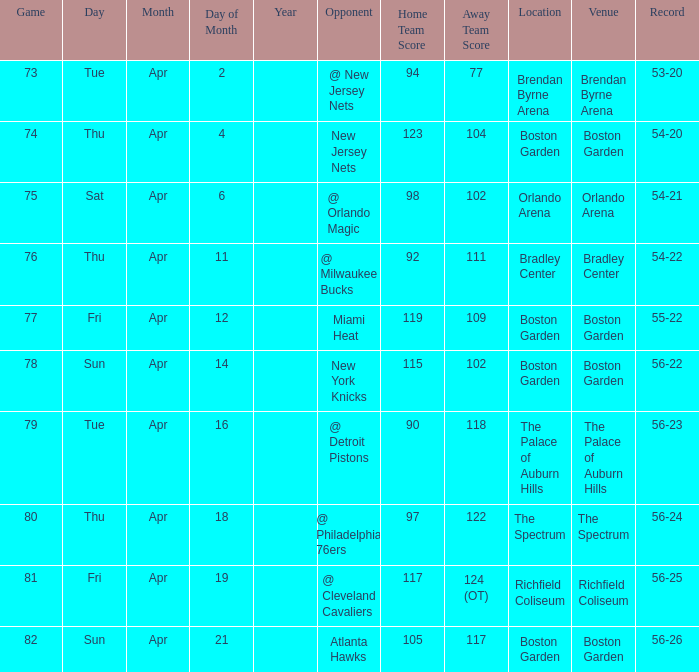Where was game 78 held? Boston Garden. 